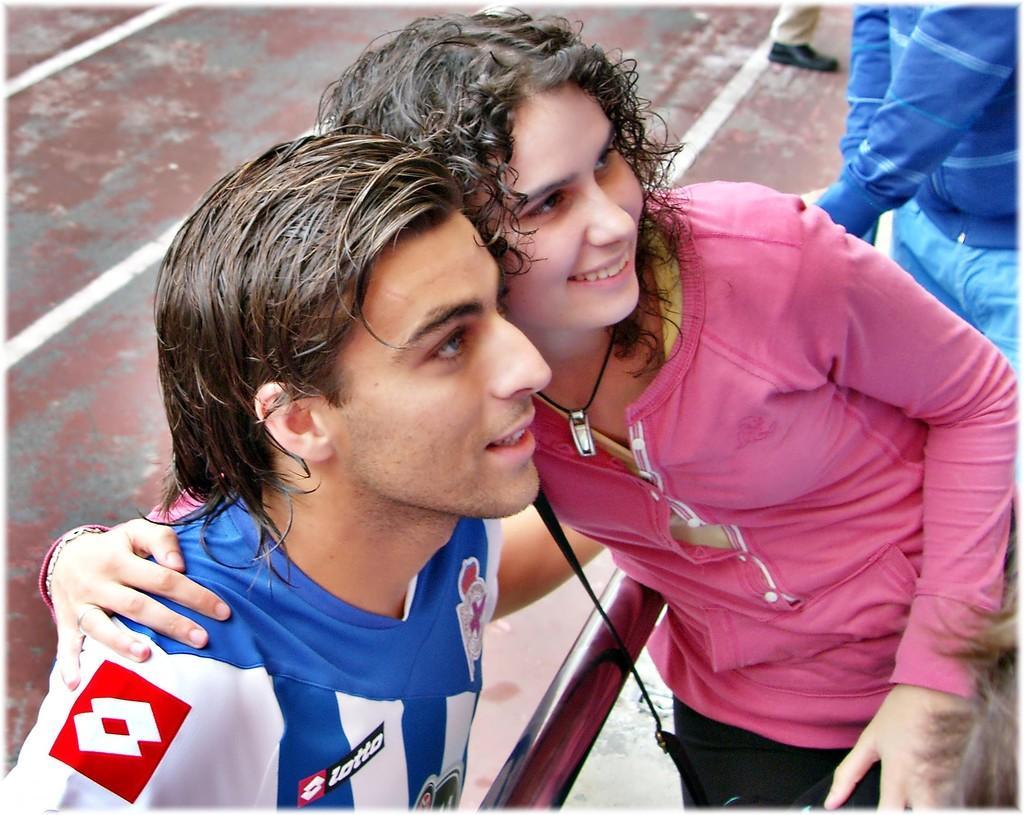Please provide a concise description of this image. In this picture there is a man who is wearing t-shirt. He is standing near to the woman who is green color dress. On the top right corner there is another man who is standing near to the fencing. 